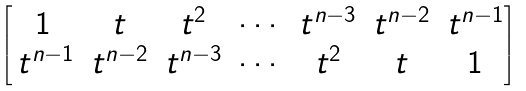<formula> <loc_0><loc_0><loc_500><loc_500>\begin{bmatrix} 1 & t & t ^ { 2 } & \cdots & t ^ { n - 3 } & t ^ { n - 2 } & t ^ { n - 1 } \\ \, t ^ { n - 1 } & t ^ { n - 2 } & t ^ { n - 3 } & \cdots & t ^ { 2 } & t & 1 \end{bmatrix}</formula> 